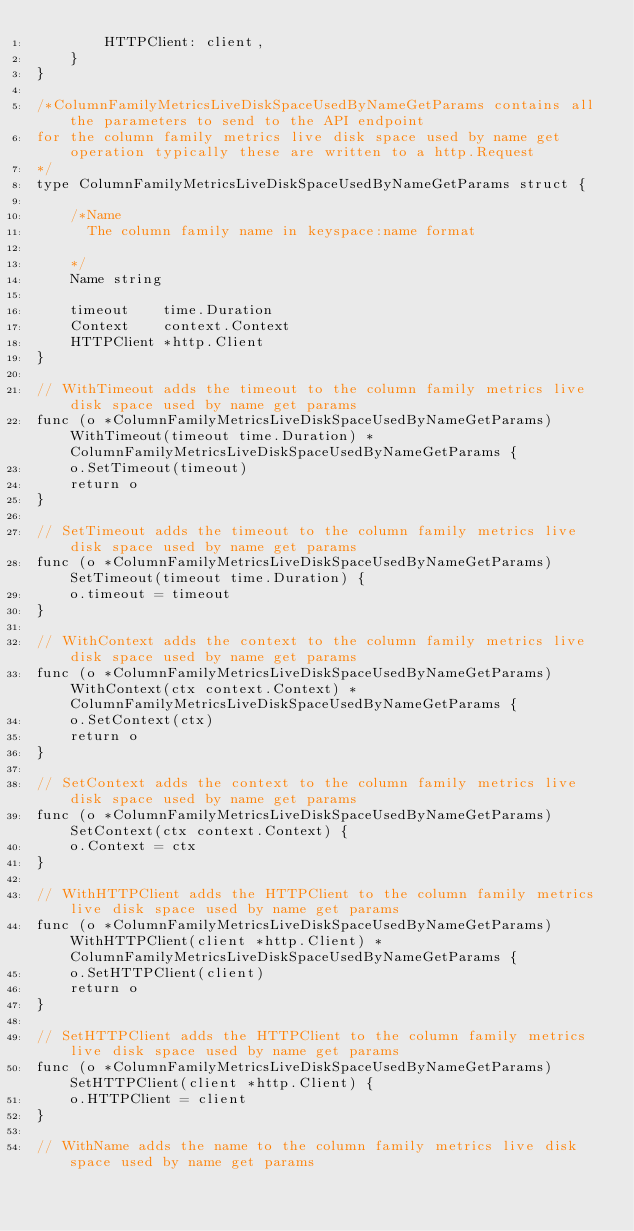<code> <loc_0><loc_0><loc_500><loc_500><_Go_>		HTTPClient: client,
	}
}

/*ColumnFamilyMetricsLiveDiskSpaceUsedByNameGetParams contains all the parameters to send to the API endpoint
for the column family metrics live disk space used by name get operation typically these are written to a http.Request
*/
type ColumnFamilyMetricsLiveDiskSpaceUsedByNameGetParams struct {

	/*Name
	  The column family name in keyspace:name format

	*/
	Name string

	timeout    time.Duration
	Context    context.Context
	HTTPClient *http.Client
}

// WithTimeout adds the timeout to the column family metrics live disk space used by name get params
func (o *ColumnFamilyMetricsLiveDiskSpaceUsedByNameGetParams) WithTimeout(timeout time.Duration) *ColumnFamilyMetricsLiveDiskSpaceUsedByNameGetParams {
	o.SetTimeout(timeout)
	return o
}

// SetTimeout adds the timeout to the column family metrics live disk space used by name get params
func (o *ColumnFamilyMetricsLiveDiskSpaceUsedByNameGetParams) SetTimeout(timeout time.Duration) {
	o.timeout = timeout
}

// WithContext adds the context to the column family metrics live disk space used by name get params
func (o *ColumnFamilyMetricsLiveDiskSpaceUsedByNameGetParams) WithContext(ctx context.Context) *ColumnFamilyMetricsLiveDiskSpaceUsedByNameGetParams {
	o.SetContext(ctx)
	return o
}

// SetContext adds the context to the column family metrics live disk space used by name get params
func (o *ColumnFamilyMetricsLiveDiskSpaceUsedByNameGetParams) SetContext(ctx context.Context) {
	o.Context = ctx
}

// WithHTTPClient adds the HTTPClient to the column family metrics live disk space used by name get params
func (o *ColumnFamilyMetricsLiveDiskSpaceUsedByNameGetParams) WithHTTPClient(client *http.Client) *ColumnFamilyMetricsLiveDiskSpaceUsedByNameGetParams {
	o.SetHTTPClient(client)
	return o
}

// SetHTTPClient adds the HTTPClient to the column family metrics live disk space used by name get params
func (o *ColumnFamilyMetricsLiveDiskSpaceUsedByNameGetParams) SetHTTPClient(client *http.Client) {
	o.HTTPClient = client
}

// WithName adds the name to the column family metrics live disk space used by name get params</code> 